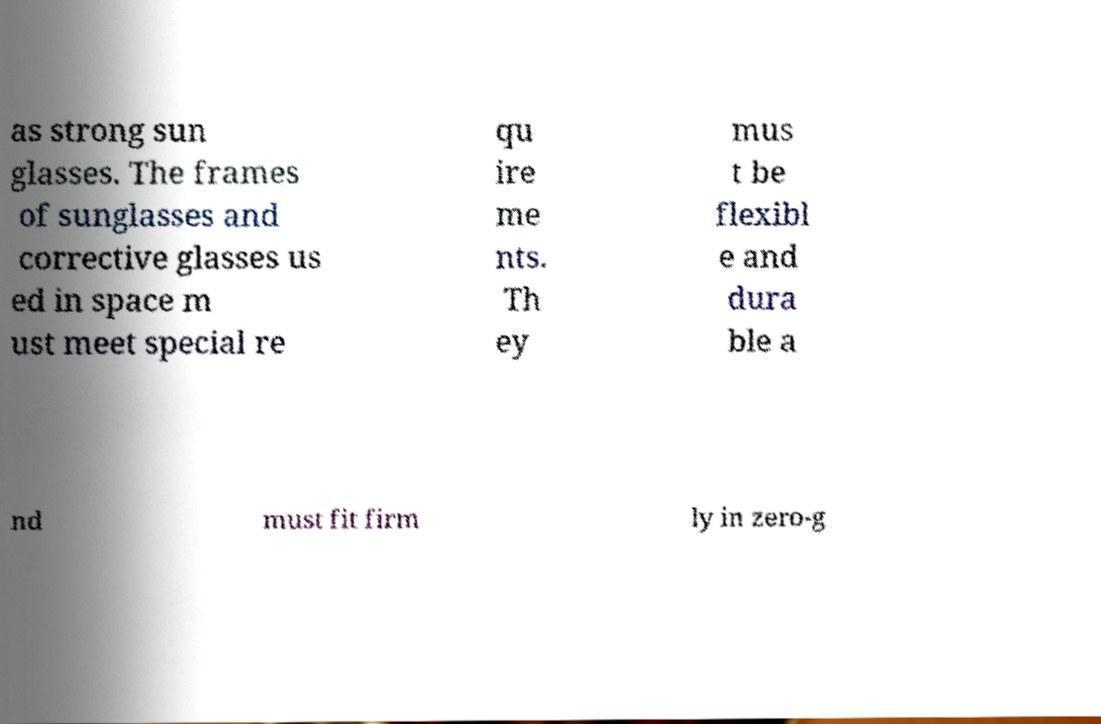Please read and relay the text visible in this image. What does it say? as strong sun glasses. The frames of sunglasses and corrective glasses us ed in space m ust meet special re qu ire me nts. Th ey mus t be flexibl e and dura ble a nd must fit firm ly in zero-g 